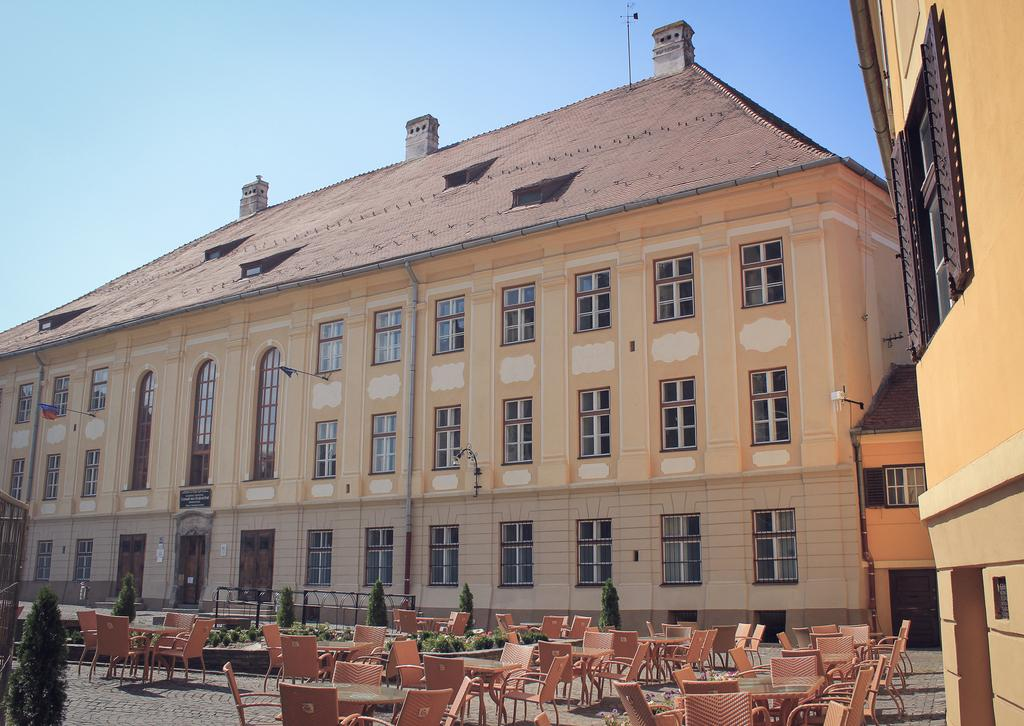What is visible at the top of the image? The sky is visible at the top of the image. What type of structures can be seen in the image? There are buildings in the image. What architectural features are present in the buildings? Windows and doors are visible in the image. What type of barrier is present in the image? An iron grill is in the image. What type of vegetation is at the bottom of the image? Plants are at the bottom of the image. What type of surface is visible at the bottom of the image? The floor is visible at the bottom of the image. What type of furniture is present at the bottom of the image? Chairs and tables are in the image at the bottom. What type of alley is visible in the image? There is no alley present in the image. What type of journey is being depicted in the image? The image does not depict a journey; it shows a scene with buildings, plants, and furniture. 